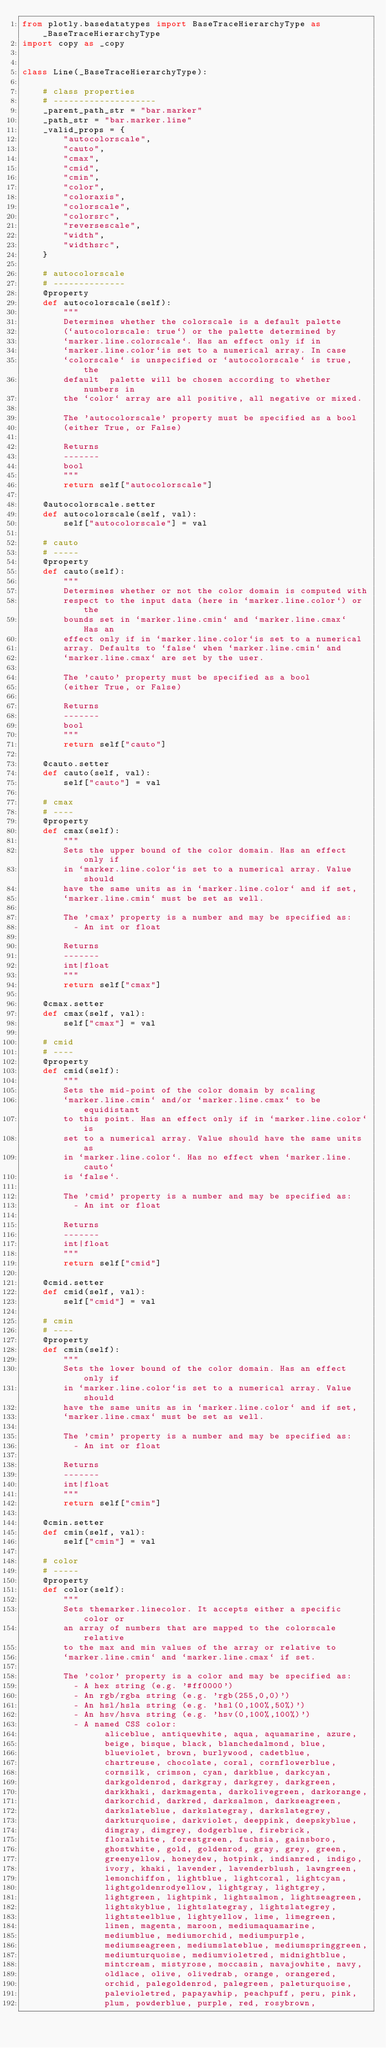Convert code to text. <code><loc_0><loc_0><loc_500><loc_500><_Python_>from plotly.basedatatypes import BaseTraceHierarchyType as _BaseTraceHierarchyType
import copy as _copy


class Line(_BaseTraceHierarchyType):

    # class properties
    # --------------------
    _parent_path_str = "bar.marker"
    _path_str = "bar.marker.line"
    _valid_props = {
        "autocolorscale",
        "cauto",
        "cmax",
        "cmid",
        "cmin",
        "color",
        "coloraxis",
        "colorscale",
        "colorsrc",
        "reversescale",
        "width",
        "widthsrc",
    }

    # autocolorscale
    # --------------
    @property
    def autocolorscale(self):
        """
        Determines whether the colorscale is a default palette
        (`autocolorscale: true`) or the palette determined by
        `marker.line.colorscale`. Has an effect only if in
        `marker.line.color`is set to a numerical array. In case
        `colorscale` is unspecified or `autocolorscale` is true, the
        default  palette will be chosen according to whether numbers in
        the `color` array are all positive, all negative or mixed.

        The 'autocolorscale' property must be specified as a bool
        (either True, or False)

        Returns
        -------
        bool
        """
        return self["autocolorscale"]

    @autocolorscale.setter
    def autocolorscale(self, val):
        self["autocolorscale"] = val

    # cauto
    # -----
    @property
    def cauto(self):
        """
        Determines whether or not the color domain is computed with
        respect to the input data (here in `marker.line.color`) or the
        bounds set in `marker.line.cmin` and `marker.line.cmax`  Has an
        effect only if in `marker.line.color`is set to a numerical
        array. Defaults to `false` when `marker.line.cmin` and
        `marker.line.cmax` are set by the user.

        The 'cauto' property must be specified as a bool
        (either True, or False)

        Returns
        -------
        bool
        """
        return self["cauto"]

    @cauto.setter
    def cauto(self, val):
        self["cauto"] = val

    # cmax
    # ----
    @property
    def cmax(self):
        """
        Sets the upper bound of the color domain. Has an effect only if
        in `marker.line.color`is set to a numerical array. Value should
        have the same units as in `marker.line.color` and if set,
        `marker.line.cmin` must be set as well.

        The 'cmax' property is a number and may be specified as:
          - An int or float

        Returns
        -------
        int|float
        """
        return self["cmax"]

    @cmax.setter
    def cmax(self, val):
        self["cmax"] = val

    # cmid
    # ----
    @property
    def cmid(self):
        """
        Sets the mid-point of the color domain by scaling
        `marker.line.cmin` and/or `marker.line.cmax` to be equidistant
        to this point. Has an effect only if in `marker.line.color`is
        set to a numerical array. Value should have the same units as
        in `marker.line.color`. Has no effect when `marker.line.cauto`
        is `false`.

        The 'cmid' property is a number and may be specified as:
          - An int or float

        Returns
        -------
        int|float
        """
        return self["cmid"]

    @cmid.setter
    def cmid(self, val):
        self["cmid"] = val

    # cmin
    # ----
    @property
    def cmin(self):
        """
        Sets the lower bound of the color domain. Has an effect only if
        in `marker.line.color`is set to a numerical array. Value should
        have the same units as in `marker.line.color` and if set,
        `marker.line.cmax` must be set as well.

        The 'cmin' property is a number and may be specified as:
          - An int or float

        Returns
        -------
        int|float
        """
        return self["cmin"]

    @cmin.setter
    def cmin(self, val):
        self["cmin"] = val

    # color
    # -----
    @property
    def color(self):
        """
        Sets themarker.linecolor. It accepts either a specific color or
        an array of numbers that are mapped to the colorscale relative
        to the max and min values of the array or relative to
        `marker.line.cmin` and `marker.line.cmax` if set.

        The 'color' property is a color and may be specified as:
          - A hex string (e.g. '#ff0000')
          - An rgb/rgba string (e.g. 'rgb(255,0,0)')
          - An hsl/hsla string (e.g. 'hsl(0,100%,50%)')
          - An hsv/hsva string (e.g. 'hsv(0,100%,100%)')
          - A named CSS color:
                aliceblue, antiquewhite, aqua, aquamarine, azure,
                beige, bisque, black, blanchedalmond, blue,
                blueviolet, brown, burlywood, cadetblue,
                chartreuse, chocolate, coral, cornflowerblue,
                cornsilk, crimson, cyan, darkblue, darkcyan,
                darkgoldenrod, darkgray, darkgrey, darkgreen,
                darkkhaki, darkmagenta, darkolivegreen, darkorange,
                darkorchid, darkred, darksalmon, darkseagreen,
                darkslateblue, darkslategray, darkslategrey,
                darkturquoise, darkviolet, deeppink, deepskyblue,
                dimgray, dimgrey, dodgerblue, firebrick,
                floralwhite, forestgreen, fuchsia, gainsboro,
                ghostwhite, gold, goldenrod, gray, grey, green,
                greenyellow, honeydew, hotpink, indianred, indigo,
                ivory, khaki, lavender, lavenderblush, lawngreen,
                lemonchiffon, lightblue, lightcoral, lightcyan,
                lightgoldenrodyellow, lightgray, lightgrey,
                lightgreen, lightpink, lightsalmon, lightseagreen,
                lightskyblue, lightslategray, lightslategrey,
                lightsteelblue, lightyellow, lime, limegreen,
                linen, magenta, maroon, mediumaquamarine,
                mediumblue, mediumorchid, mediumpurple,
                mediumseagreen, mediumslateblue, mediumspringgreen,
                mediumturquoise, mediumvioletred, midnightblue,
                mintcream, mistyrose, moccasin, navajowhite, navy,
                oldlace, olive, olivedrab, orange, orangered,
                orchid, palegoldenrod, palegreen, paleturquoise,
                palevioletred, papayawhip, peachpuff, peru, pink,
                plum, powderblue, purple, red, rosybrown,</code> 